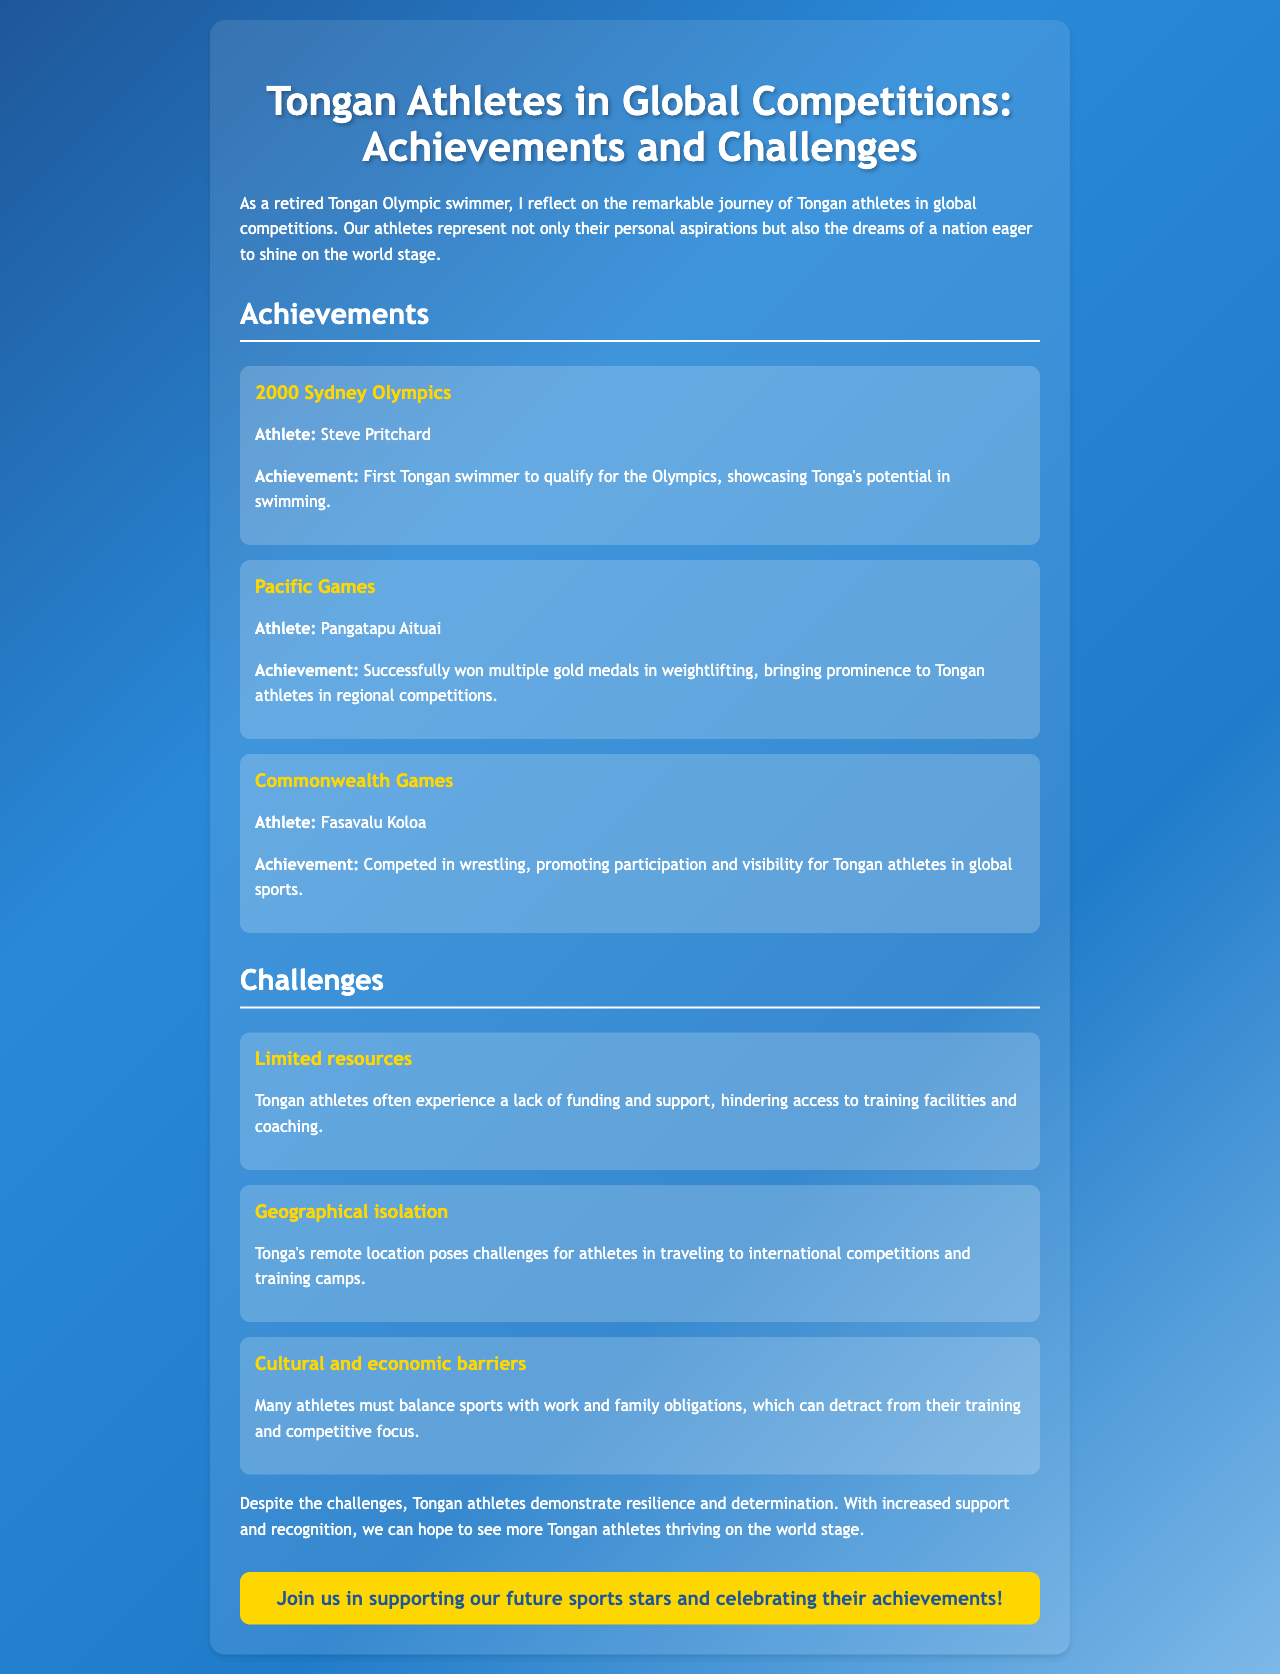What year did Steve Pritchard compete in the Olympics? The document states that Steve Pritchard competed in the 2000 Sydney Olympics.
Answer: 2000 What sport did Pangatapu Aituai excel in? The document indicates that Pangatapu Aituai won multiple gold medals in weightlifting.
Answer: Weightlifting Who is mentioned as competing in wrestling at the Commonwealth Games? Fasavalu Koloa is mentioned as the athlete who competed in wrestling at the Commonwealth Games.
Answer: Fasavalu Koloa What is one major challenge faced by Tongan athletes? The document discusses multiple challenges, one of which is limited resources affecting funding and support.
Answer: Limited resources How does geographical isolation affect Tongan athletes? The document states that Tonga's remote location poses challenges for traveling to international competitions.
Answer: Traveling challenges What role does cultural obligation play for Tongan athletes? The document mentions that many athletes must balance sports with work and family obligations, impacting their training.
Answer: Balancing obligations What is the overall theme of the brochure? The document reflects on the achievements and challenges of Tongan athletes in global competitions.
Answer: Achievements and challenges What is the call to action in the brochure? The call to action encourages support for future sports stars and celebration of their achievements.
Answer: Support our future sports stars 